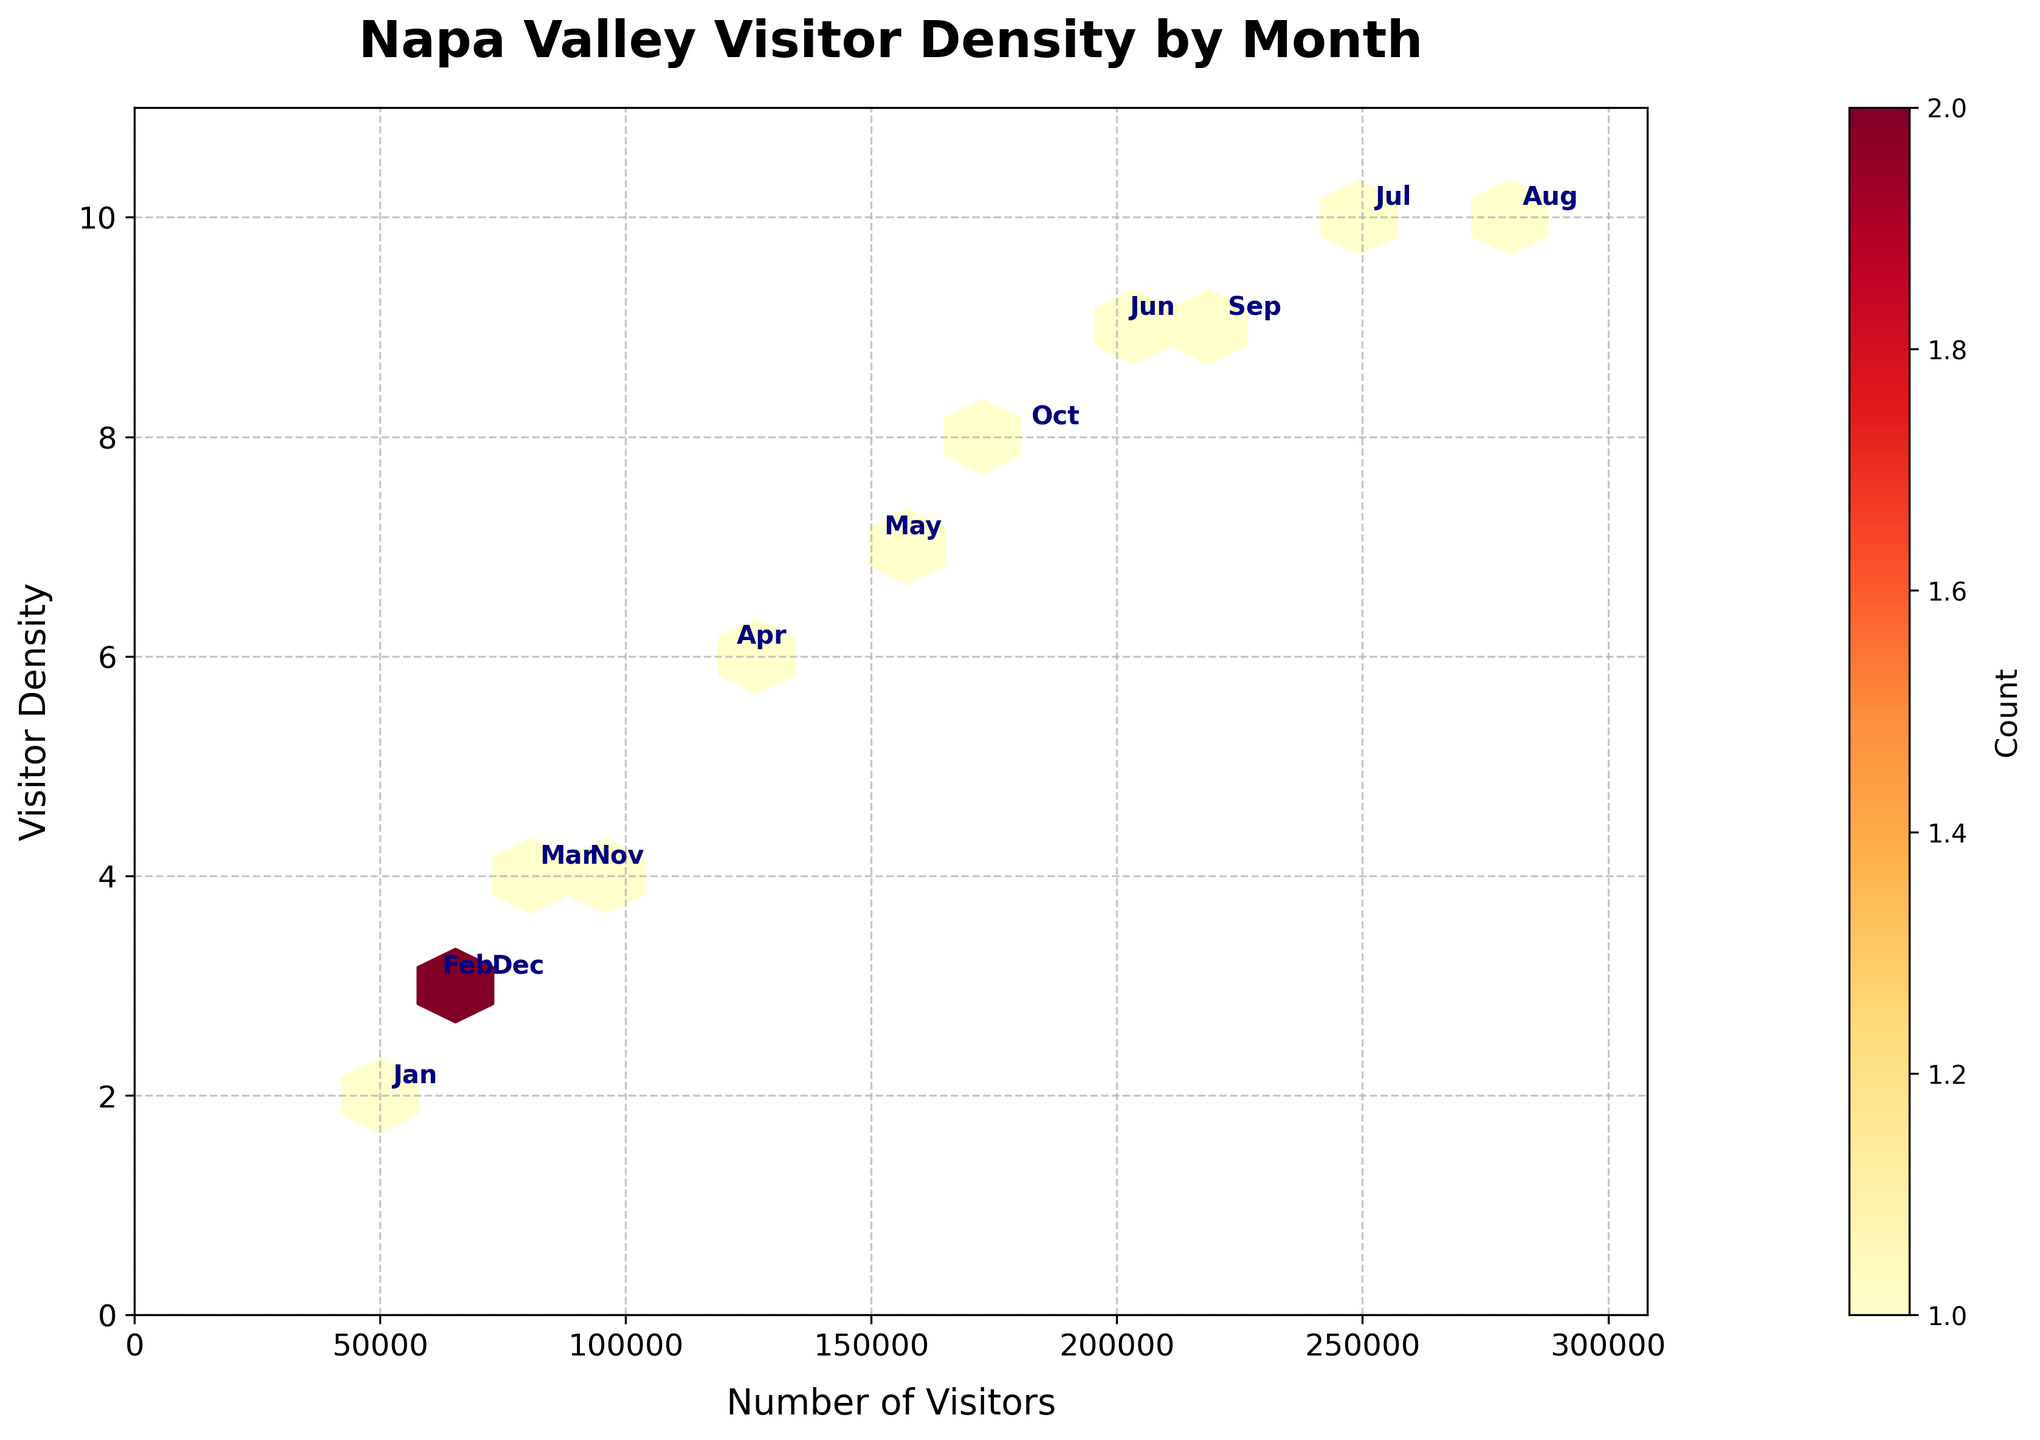What is the title of the hexbin plot? The title of the figure can be found at the top of the plot. It is written in a larger font size and bold letters.
Answer: Napa Valley Visitor Density by Month How many months are annotated on the hexbin plot? The annotations refer to the abbreviated names of the months next to the data points. By counting these annotations, you will find how many months are represented.
Answer: 12 What is the maximum number of visitors shown on the plot? The x-axis represents the number of visitors. By looking at the farthest right data point on the x-axis, you find the month with the highest visitor count.
Answer: 280000 Which month has the highest visitor density? The y-axis represents visitor density. By looking at the highest point on the y-axis, you can determine which month has the highest density.
Answer: August Which months have the same highest visitor density? Identify the points with the highest y-coordinate, which represent visitor density. Multiple points at this coordinate indicate months with the same maximum density.
Answer: July and August What is the visitor density in September? Locate the annotation for September and observe the y-coordinate of the respective data point to find the visitor density.
Answer: 9 What is the difference in the number of visitors between June and September? Locate the data points for June and September on the x-axis. Subtract the number of visitors in September from those in June to find the difference.
Answer: 20000 Which month has the lowest number of visitors, and what is their density? Look for the data point closest to the origin on the x-axis, indicating the lowest number of visitors. Read its corresponding y-coordinate for the density.
Answer: January, 2 Does April have a higher or lower visitor density than November? Compare the y-coordinates of the data points annotated with April and November to determine which is higher.
Answer: Higher What range of visitor numbers corresponds to the densest regions of the plot? Examine the hexbin color intensity on the plot, which indicates denser regions, and note the range on the x-axis corresponding to these regions.
Answer: 200000 - 280000 